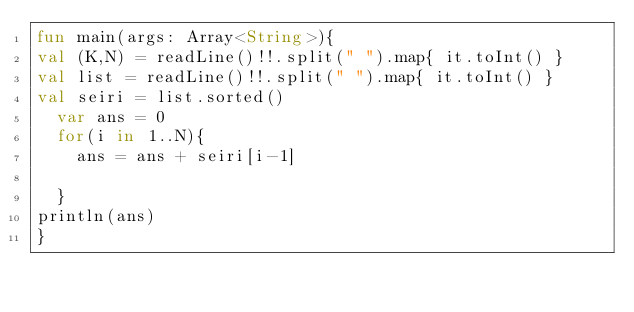<code> <loc_0><loc_0><loc_500><loc_500><_Kotlin_>fun main(args: Array<String>){
val (K,N) = readLine()!!.split(" ").map{ it.toInt() }
val list = readLine()!!.split(" ").map{ it.toInt() }
val seiri = list.sorted()
  var ans = 0
  for(i in 1..N){
    ans = ans + seiri[i-1]
    
  }
println(ans)
}</code> 